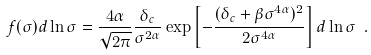<formula> <loc_0><loc_0><loc_500><loc_500>f ( \sigma ) d \ln \sigma = \frac { 4 \alpha } { \sqrt { 2 \pi } } \frac { \delta _ { c } } { \sigma ^ { 2 \alpha } } \exp \left [ - \frac { ( \delta _ { c } + \beta \sigma ^ { 4 \alpha } ) ^ { 2 } } { 2 \sigma ^ { 4 \alpha } } \right ] d \ln \sigma \ .</formula> 